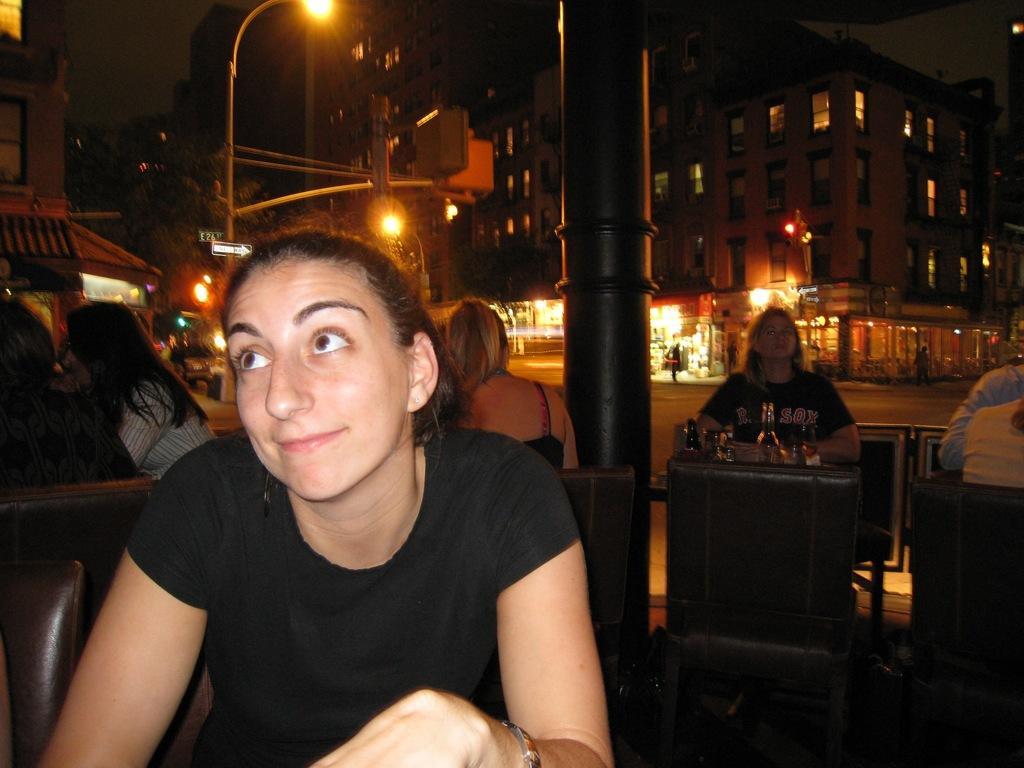Can you describe this image briefly? In the foreground I can see a group of people are sitting on the chairs in front of a table and bottles. In the background I can see buildings, light poles, trees and the sky. This image is taken may be during night. 